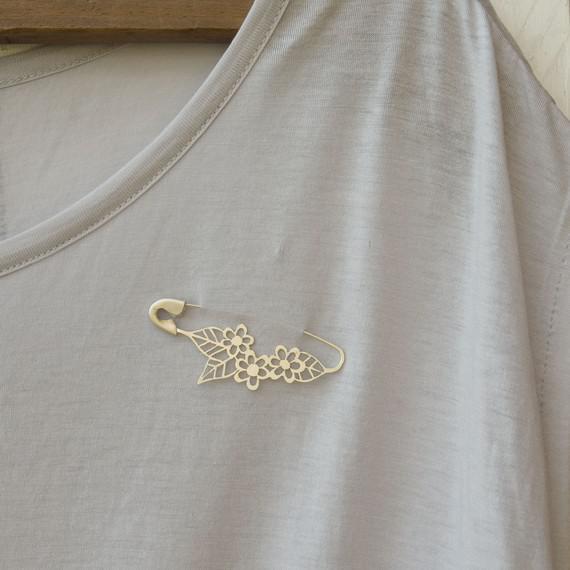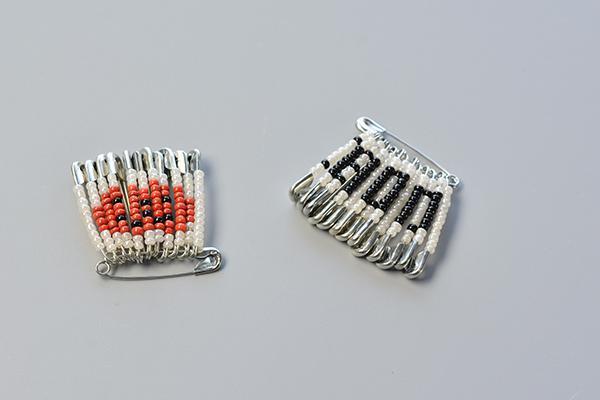The first image is the image on the left, the second image is the image on the right. Analyze the images presented: Is the assertion "The right image shows only one decorated pin." valid? Answer yes or no. No. 